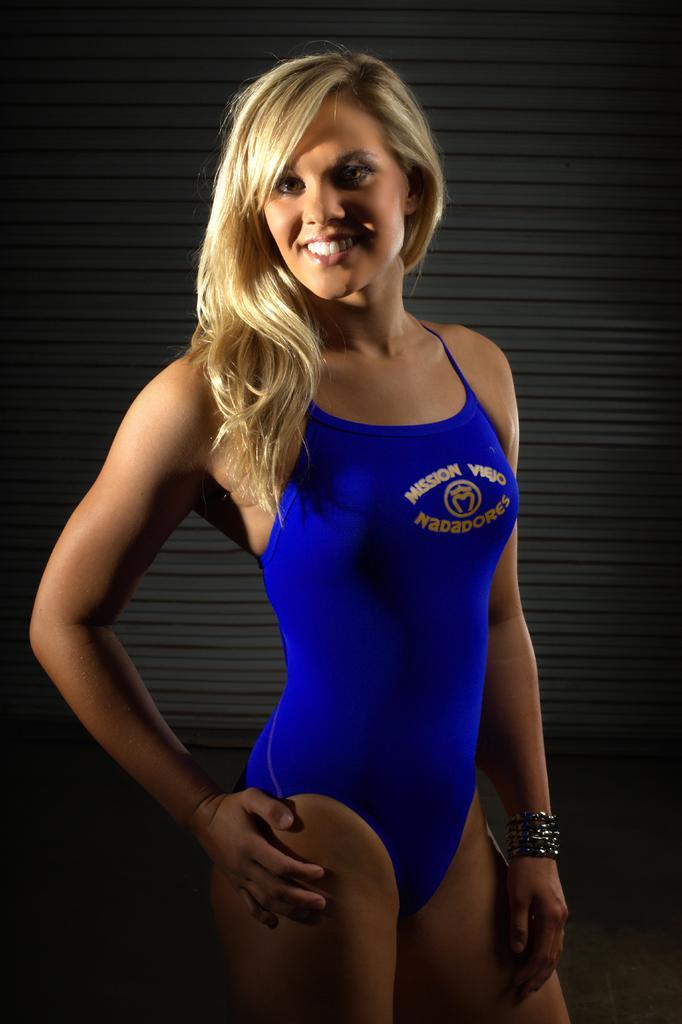Describe this image in one or two sentences. In the image there is a woman, she is wearing a swimsuit and smiling. 